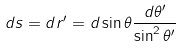<formula> <loc_0><loc_0><loc_500><loc_500>d s = d r ^ { \prime } = d \sin \theta \frac { d \theta ^ { \prime } } { \sin ^ { 2 } \theta ^ { \prime } }</formula> 